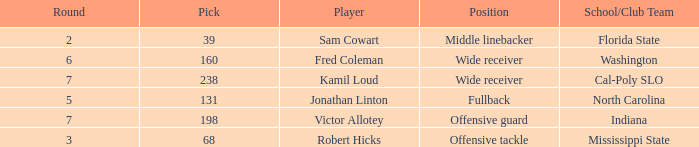Which School/Club Team has a Pick of 198? Indiana. 